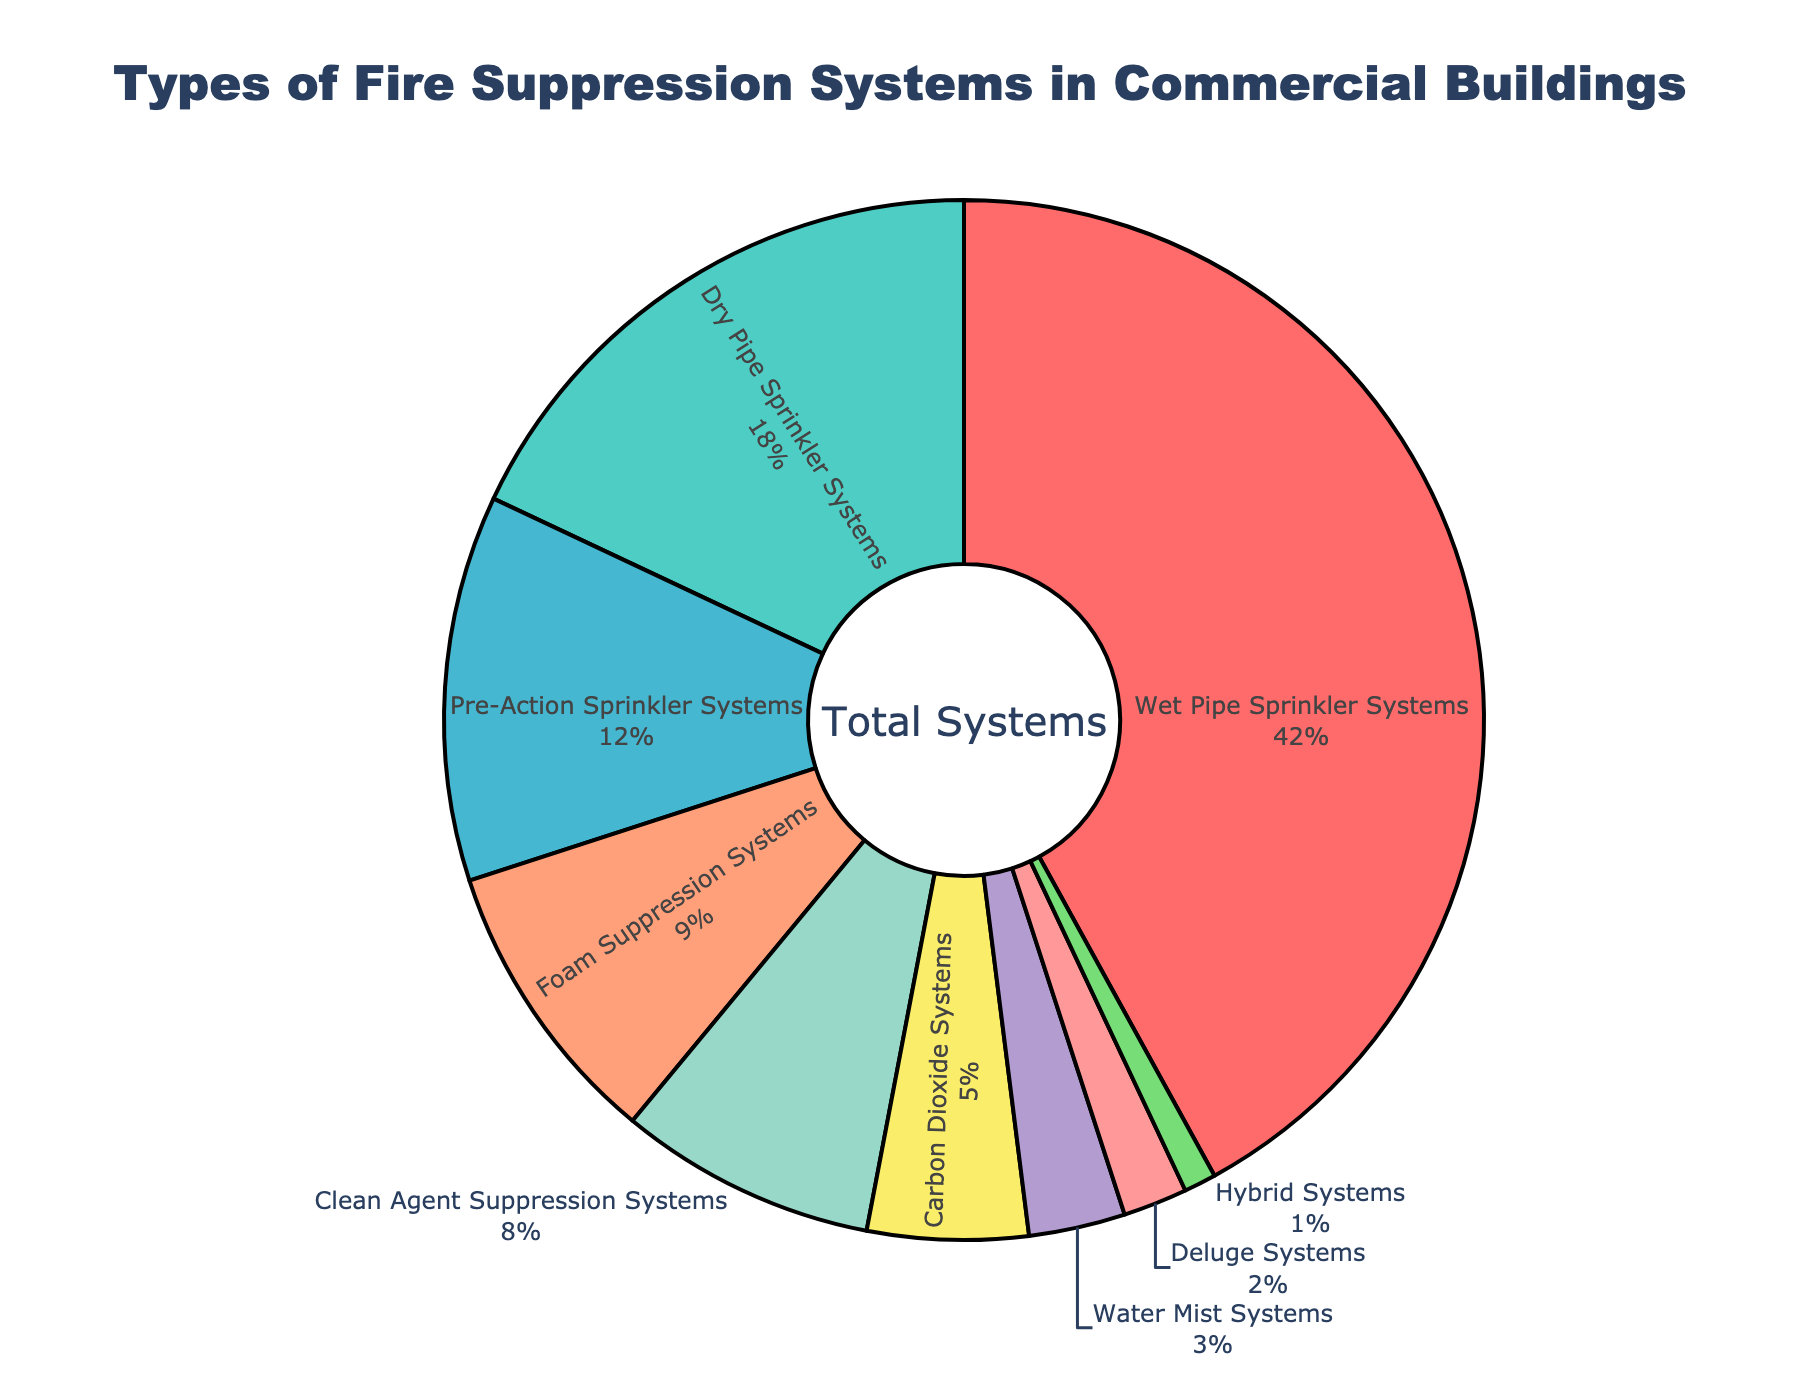Which fire suppression system is represented by the largest percentage? Identify the segment with the largest slice in the pie chart.
Answer: Wet Pipe Sprinkler Systems How much larger is the percentage of Wet Pipe Sprinkler Systems compared to Dry Pipe Sprinkler Systems? Subtract the percentage of Dry Pipe Sprinkler Systems (18%) from Wet Pipe Sprinkler Systems (42%). Calculation: 42 - 18 = 24
Answer: 24% What is the combined percentage of Pre-Action Sprinkler Systems and Foam Suppression Systems? Add the percentages of Pre-Action Sprinkler Systems (12%) and Foam Suppression Systems (9%). Calculation: 12 + 9 = 21
Answer: 21% Which three fire suppression systems have the smallest percentages? Identify the three smallest segments in the pie chart. These are Hybrid Systems, Deluge Systems, and Water Mist Systems.
Answer: Hybrid Systems, Deluge Systems, and Water Mist Systems Is the percentage of Clean Agent Suppression Systems greater than that of Carbon Dioxide Systems? Compare the percentages of Clean Agent Suppression Systems (8%) and Carbon Dioxide Systems (5%). Because 8 > 5, Clean Agent Suppression Systems have a higher percentage.
Answer: Yes What is the total percentage of all fire suppression systems excluding Wet Pipe Sprinkler Systems? Subtract the percentage of Wet Pipe Sprinkler Systems (42%) from the total percentage (100%). Calculation: 100 - 42 = 58
Answer: 58% By how much does the percentage of Dry Pipe Sprinkler Systems exceed the percentage of Water Mist Systems? Subtract the percentage of Water Mist Systems (3%) from Dry Pipe Sprinkler Systems (18%). Calculation: 18 - 3 = 15
Answer: 15% What percentage of the total is made up by the three largest fire suppression systems? Add the percentages of Wet Pipe Sprinkler Systems (42%), Dry Pipe Sprinkler Systems (18%), and Pre-Action Sprinkler Systems (12%). Calculation: 42 + 18 + 12 = 72
Answer: 72% Which system has a percentage that rounds to approximately 10% and what is the exact percentage? Identify the visual section close to 10%, which is Foam Suppression Systems, and check the exact percentage from the data. The exact value is 9%.
Answer: Foam Suppression Systems, 9% What is the average percentage of the systems with less than 10%? (List of such systems: Foam Suppression Systems, Clean Agent Suppression Systems, Carbon Dioxide Systems, Water Mist Systems, Deluge Systems, Hybrid Systems) Add the percentages of these systems and divide by the number of these systems. Calculation: (9 + 8 + 5 + 3 + 2 + 1) / 6 = 28 / 6 ≈ 4.67
Answer: 4.67% 